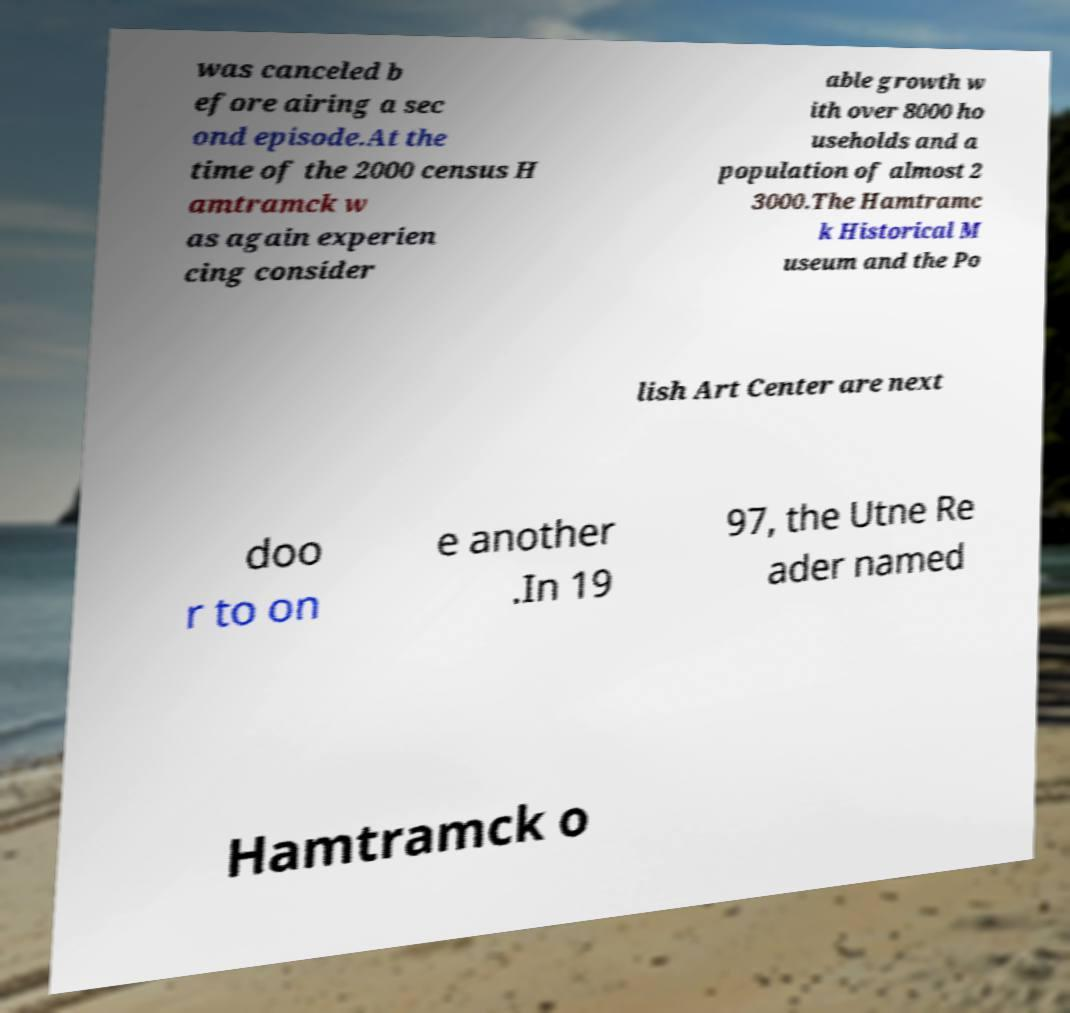Could you extract and type out the text from this image? was canceled b efore airing a sec ond episode.At the time of the 2000 census H amtramck w as again experien cing consider able growth w ith over 8000 ho useholds and a population of almost 2 3000.The Hamtramc k Historical M useum and the Po lish Art Center are next doo r to on e another .In 19 97, the Utne Re ader named Hamtramck o 